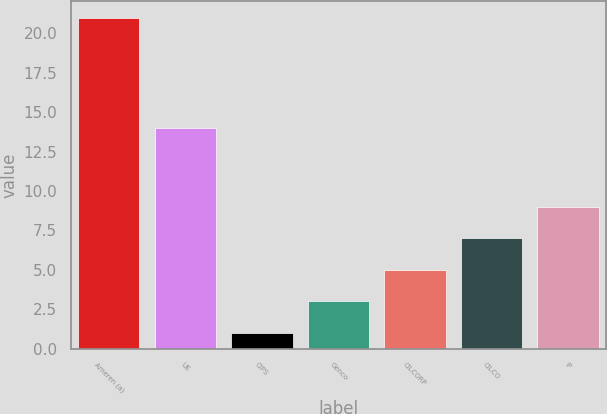Convert chart to OTSL. <chart><loc_0><loc_0><loc_500><loc_500><bar_chart><fcel>Ameren (a)<fcel>UE<fcel>CIPS<fcel>Genco<fcel>CILCORP<fcel>CILCO<fcel>IP<nl><fcel>21<fcel>14<fcel>1<fcel>3<fcel>5<fcel>7<fcel>9<nl></chart> 